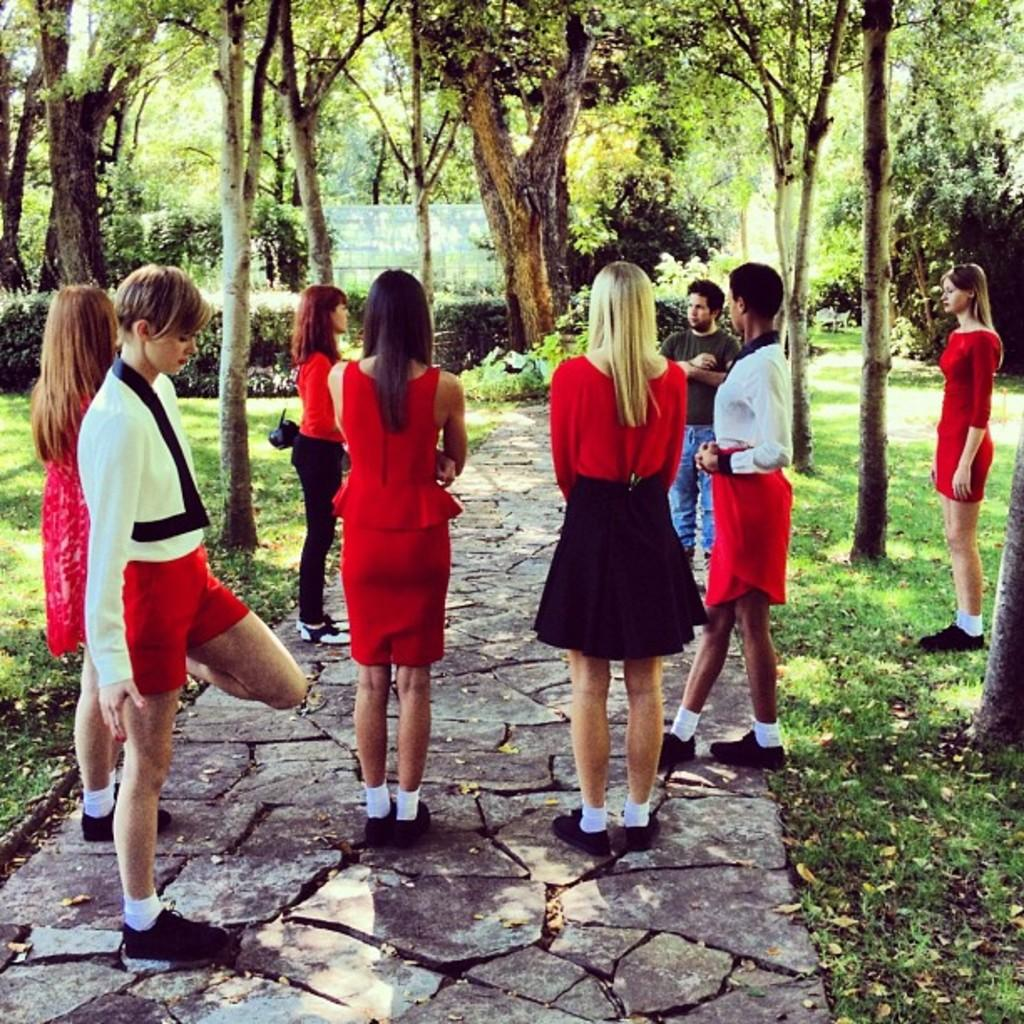What is the surface that the people are standing on in the image? The surface is not specified in the facts, but it is mentioned that there are people standing on it. Can you describe the woman's attire in the image? The woman is wearing a bag in the image. What type of vegetation can be seen in the image? There is grass, trees, and plants visible in the image. How many sisters are present in the image? There is no mention of sisters in the image, so it cannot be determined from the facts provided. 